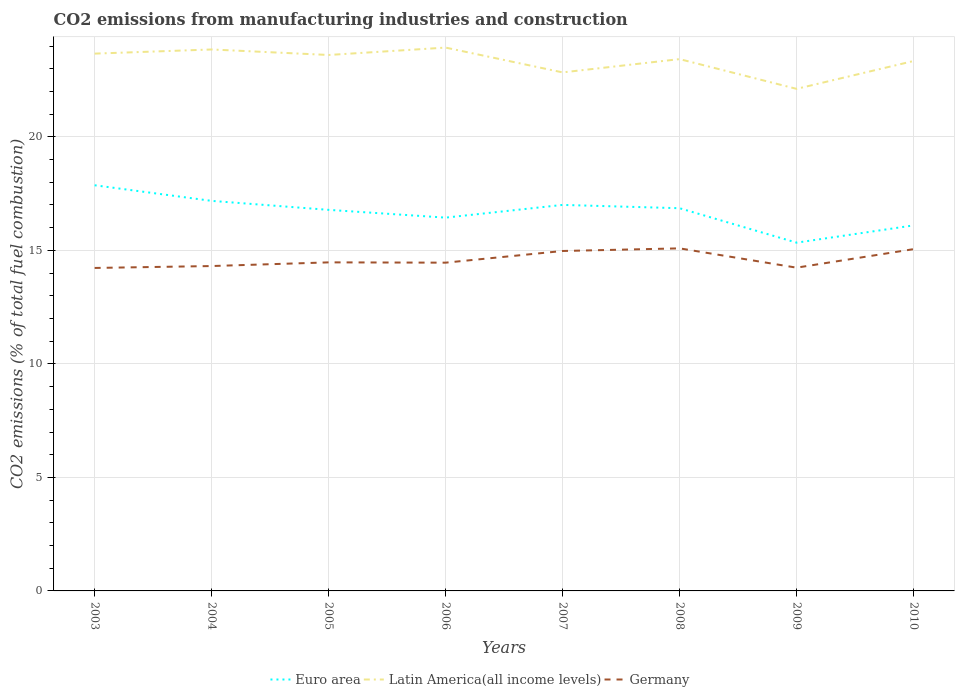How many different coloured lines are there?
Keep it short and to the point. 3. Across all years, what is the maximum amount of CO2 emitted in Euro area?
Provide a succinct answer. 15.34. What is the total amount of CO2 emitted in Germany in the graph?
Your answer should be very brief. -0.08. What is the difference between the highest and the second highest amount of CO2 emitted in Euro area?
Make the answer very short. 2.53. Is the amount of CO2 emitted in Euro area strictly greater than the amount of CO2 emitted in Germany over the years?
Give a very brief answer. No. How many years are there in the graph?
Provide a succinct answer. 8. What is the difference between two consecutive major ticks on the Y-axis?
Your answer should be very brief. 5. Does the graph contain any zero values?
Offer a terse response. No. Does the graph contain grids?
Give a very brief answer. Yes. Where does the legend appear in the graph?
Provide a succinct answer. Bottom center. How are the legend labels stacked?
Your answer should be compact. Horizontal. What is the title of the graph?
Provide a short and direct response. CO2 emissions from manufacturing industries and construction. Does "New Caledonia" appear as one of the legend labels in the graph?
Your response must be concise. No. What is the label or title of the X-axis?
Your response must be concise. Years. What is the label or title of the Y-axis?
Make the answer very short. CO2 emissions (% of total fuel combustion). What is the CO2 emissions (% of total fuel combustion) of Euro area in 2003?
Your answer should be very brief. 17.87. What is the CO2 emissions (% of total fuel combustion) in Latin America(all income levels) in 2003?
Give a very brief answer. 23.67. What is the CO2 emissions (% of total fuel combustion) in Germany in 2003?
Make the answer very short. 14.23. What is the CO2 emissions (% of total fuel combustion) of Euro area in 2004?
Offer a terse response. 17.18. What is the CO2 emissions (% of total fuel combustion) of Latin America(all income levels) in 2004?
Your answer should be compact. 23.85. What is the CO2 emissions (% of total fuel combustion) of Germany in 2004?
Ensure brevity in your answer.  14.31. What is the CO2 emissions (% of total fuel combustion) in Euro area in 2005?
Keep it short and to the point. 16.78. What is the CO2 emissions (% of total fuel combustion) in Latin America(all income levels) in 2005?
Offer a very short reply. 23.61. What is the CO2 emissions (% of total fuel combustion) in Germany in 2005?
Provide a succinct answer. 14.47. What is the CO2 emissions (% of total fuel combustion) of Euro area in 2006?
Give a very brief answer. 16.44. What is the CO2 emissions (% of total fuel combustion) in Latin America(all income levels) in 2006?
Keep it short and to the point. 23.93. What is the CO2 emissions (% of total fuel combustion) of Germany in 2006?
Your response must be concise. 14.46. What is the CO2 emissions (% of total fuel combustion) in Euro area in 2007?
Offer a terse response. 17. What is the CO2 emissions (% of total fuel combustion) of Latin America(all income levels) in 2007?
Your answer should be very brief. 22.84. What is the CO2 emissions (% of total fuel combustion) in Germany in 2007?
Your answer should be very brief. 14.97. What is the CO2 emissions (% of total fuel combustion) in Euro area in 2008?
Your answer should be very brief. 16.86. What is the CO2 emissions (% of total fuel combustion) of Latin America(all income levels) in 2008?
Your response must be concise. 23.42. What is the CO2 emissions (% of total fuel combustion) of Germany in 2008?
Provide a succinct answer. 15.09. What is the CO2 emissions (% of total fuel combustion) in Euro area in 2009?
Provide a succinct answer. 15.34. What is the CO2 emissions (% of total fuel combustion) in Latin America(all income levels) in 2009?
Offer a very short reply. 22.11. What is the CO2 emissions (% of total fuel combustion) of Germany in 2009?
Make the answer very short. 14.24. What is the CO2 emissions (% of total fuel combustion) of Euro area in 2010?
Offer a terse response. 16.1. What is the CO2 emissions (% of total fuel combustion) of Latin America(all income levels) in 2010?
Provide a succinct answer. 23.34. What is the CO2 emissions (% of total fuel combustion) in Germany in 2010?
Your answer should be compact. 15.05. Across all years, what is the maximum CO2 emissions (% of total fuel combustion) of Euro area?
Keep it short and to the point. 17.87. Across all years, what is the maximum CO2 emissions (% of total fuel combustion) in Latin America(all income levels)?
Provide a succinct answer. 23.93. Across all years, what is the maximum CO2 emissions (% of total fuel combustion) of Germany?
Make the answer very short. 15.09. Across all years, what is the minimum CO2 emissions (% of total fuel combustion) of Euro area?
Your answer should be very brief. 15.34. Across all years, what is the minimum CO2 emissions (% of total fuel combustion) in Latin America(all income levels)?
Keep it short and to the point. 22.11. Across all years, what is the minimum CO2 emissions (% of total fuel combustion) of Germany?
Your answer should be very brief. 14.23. What is the total CO2 emissions (% of total fuel combustion) of Euro area in the graph?
Your answer should be compact. 133.58. What is the total CO2 emissions (% of total fuel combustion) of Latin America(all income levels) in the graph?
Your answer should be compact. 186.77. What is the total CO2 emissions (% of total fuel combustion) of Germany in the graph?
Provide a succinct answer. 116.82. What is the difference between the CO2 emissions (% of total fuel combustion) of Euro area in 2003 and that in 2004?
Offer a very short reply. 0.69. What is the difference between the CO2 emissions (% of total fuel combustion) of Latin America(all income levels) in 2003 and that in 2004?
Provide a succinct answer. -0.18. What is the difference between the CO2 emissions (% of total fuel combustion) in Germany in 2003 and that in 2004?
Keep it short and to the point. -0.08. What is the difference between the CO2 emissions (% of total fuel combustion) of Euro area in 2003 and that in 2005?
Ensure brevity in your answer.  1.08. What is the difference between the CO2 emissions (% of total fuel combustion) in Latin America(all income levels) in 2003 and that in 2005?
Provide a succinct answer. 0.06. What is the difference between the CO2 emissions (% of total fuel combustion) in Germany in 2003 and that in 2005?
Keep it short and to the point. -0.25. What is the difference between the CO2 emissions (% of total fuel combustion) in Euro area in 2003 and that in 2006?
Offer a very short reply. 1.43. What is the difference between the CO2 emissions (% of total fuel combustion) of Latin America(all income levels) in 2003 and that in 2006?
Give a very brief answer. -0.27. What is the difference between the CO2 emissions (% of total fuel combustion) of Germany in 2003 and that in 2006?
Make the answer very short. -0.23. What is the difference between the CO2 emissions (% of total fuel combustion) of Euro area in 2003 and that in 2007?
Offer a very short reply. 0.87. What is the difference between the CO2 emissions (% of total fuel combustion) of Latin America(all income levels) in 2003 and that in 2007?
Make the answer very short. 0.83. What is the difference between the CO2 emissions (% of total fuel combustion) of Germany in 2003 and that in 2007?
Your answer should be compact. -0.75. What is the difference between the CO2 emissions (% of total fuel combustion) in Euro area in 2003 and that in 2008?
Provide a succinct answer. 1.01. What is the difference between the CO2 emissions (% of total fuel combustion) in Latin America(all income levels) in 2003 and that in 2008?
Your answer should be compact. 0.24. What is the difference between the CO2 emissions (% of total fuel combustion) in Germany in 2003 and that in 2008?
Your answer should be compact. -0.86. What is the difference between the CO2 emissions (% of total fuel combustion) in Euro area in 2003 and that in 2009?
Ensure brevity in your answer.  2.53. What is the difference between the CO2 emissions (% of total fuel combustion) of Latin America(all income levels) in 2003 and that in 2009?
Your answer should be compact. 1.55. What is the difference between the CO2 emissions (% of total fuel combustion) of Germany in 2003 and that in 2009?
Keep it short and to the point. -0.01. What is the difference between the CO2 emissions (% of total fuel combustion) of Euro area in 2003 and that in 2010?
Provide a short and direct response. 1.77. What is the difference between the CO2 emissions (% of total fuel combustion) in Latin America(all income levels) in 2003 and that in 2010?
Ensure brevity in your answer.  0.33. What is the difference between the CO2 emissions (% of total fuel combustion) in Germany in 2003 and that in 2010?
Offer a very short reply. -0.83. What is the difference between the CO2 emissions (% of total fuel combustion) in Euro area in 2004 and that in 2005?
Make the answer very short. 0.4. What is the difference between the CO2 emissions (% of total fuel combustion) of Latin America(all income levels) in 2004 and that in 2005?
Offer a terse response. 0.24. What is the difference between the CO2 emissions (% of total fuel combustion) in Germany in 2004 and that in 2005?
Your answer should be compact. -0.16. What is the difference between the CO2 emissions (% of total fuel combustion) of Euro area in 2004 and that in 2006?
Keep it short and to the point. 0.74. What is the difference between the CO2 emissions (% of total fuel combustion) of Latin America(all income levels) in 2004 and that in 2006?
Ensure brevity in your answer.  -0.08. What is the difference between the CO2 emissions (% of total fuel combustion) of Germany in 2004 and that in 2006?
Ensure brevity in your answer.  -0.15. What is the difference between the CO2 emissions (% of total fuel combustion) in Euro area in 2004 and that in 2007?
Provide a short and direct response. 0.18. What is the difference between the CO2 emissions (% of total fuel combustion) in Latin America(all income levels) in 2004 and that in 2007?
Your answer should be compact. 1.01. What is the difference between the CO2 emissions (% of total fuel combustion) in Germany in 2004 and that in 2007?
Give a very brief answer. -0.66. What is the difference between the CO2 emissions (% of total fuel combustion) of Euro area in 2004 and that in 2008?
Make the answer very short. 0.32. What is the difference between the CO2 emissions (% of total fuel combustion) of Latin America(all income levels) in 2004 and that in 2008?
Your answer should be very brief. 0.42. What is the difference between the CO2 emissions (% of total fuel combustion) in Germany in 2004 and that in 2008?
Keep it short and to the point. -0.78. What is the difference between the CO2 emissions (% of total fuel combustion) of Euro area in 2004 and that in 2009?
Offer a terse response. 1.84. What is the difference between the CO2 emissions (% of total fuel combustion) of Latin America(all income levels) in 2004 and that in 2009?
Your response must be concise. 1.73. What is the difference between the CO2 emissions (% of total fuel combustion) in Germany in 2004 and that in 2009?
Make the answer very short. 0.07. What is the difference between the CO2 emissions (% of total fuel combustion) of Latin America(all income levels) in 2004 and that in 2010?
Your answer should be very brief. 0.51. What is the difference between the CO2 emissions (% of total fuel combustion) of Germany in 2004 and that in 2010?
Your answer should be compact. -0.74. What is the difference between the CO2 emissions (% of total fuel combustion) in Euro area in 2005 and that in 2006?
Offer a terse response. 0.34. What is the difference between the CO2 emissions (% of total fuel combustion) of Latin America(all income levels) in 2005 and that in 2006?
Offer a very short reply. -0.33. What is the difference between the CO2 emissions (% of total fuel combustion) in Germany in 2005 and that in 2006?
Provide a short and direct response. 0.01. What is the difference between the CO2 emissions (% of total fuel combustion) in Euro area in 2005 and that in 2007?
Provide a short and direct response. -0.22. What is the difference between the CO2 emissions (% of total fuel combustion) of Latin America(all income levels) in 2005 and that in 2007?
Your response must be concise. 0.77. What is the difference between the CO2 emissions (% of total fuel combustion) in Germany in 2005 and that in 2007?
Provide a succinct answer. -0.5. What is the difference between the CO2 emissions (% of total fuel combustion) in Euro area in 2005 and that in 2008?
Make the answer very short. -0.07. What is the difference between the CO2 emissions (% of total fuel combustion) of Latin America(all income levels) in 2005 and that in 2008?
Your answer should be compact. 0.18. What is the difference between the CO2 emissions (% of total fuel combustion) of Germany in 2005 and that in 2008?
Keep it short and to the point. -0.62. What is the difference between the CO2 emissions (% of total fuel combustion) in Euro area in 2005 and that in 2009?
Provide a short and direct response. 1.44. What is the difference between the CO2 emissions (% of total fuel combustion) of Latin America(all income levels) in 2005 and that in 2009?
Your answer should be compact. 1.49. What is the difference between the CO2 emissions (% of total fuel combustion) of Germany in 2005 and that in 2009?
Your answer should be compact. 0.23. What is the difference between the CO2 emissions (% of total fuel combustion) in Euro area in 2005 and that in 2010?
Your answer should be very brief. 0.68. What is the difference between the CO2 emissions (% of total fuel combustion) of Latin America(all income levels) in 2005 and that in 2010?
Offer a very short reply. 0.27. What is the difference between the CO2 emissions (% of total fuel combustion) of Germany in 2005 and that in 2010?
Keep it short and to the point. -0.58. What is the difference between the CO2 emissions (% of total fuel combustion) of Euro area in 2006 and that in 2007?
Your answer should be very brief. -0.56. What is the difference between the CO2 emissions (% of total fuel combustion) in Latin America(all income levels) in 2006 and that in 2007?
Keep it short and to the point. 1.09. What is the difference between the CO2 emissions (% of total fuel combustion) of Germany in 2006 and that in 2007?
Provide a succinct answer. -0.51. What is the difference between the CO2 emissions (% of total fuel combustion) of Euro area in 2006 and that in 2008?
Keep it short and to the point. -0.41. What is the difference between the CO2 emissions (% of total fuel combustion) in Latin America(all income levels) in 2006 and that in 2008?
Provide a short and direct response. 0.51. What is the difference between the CO2 emissions (% of total fuel combustion) of Germany in 2006 and that in 2008?
Offer a terse response. -0.63. What is the difference between the CO2 emissions (% of total fuel combustion) in Euro area in 2006 and that in 2009?
Provide a short and direct response. 1.1. What is the difference between the CO2 emissions (% of total fuel combustion) in Latin America(all income levels) in 2006 and that in 2009?
Ensure brevity in your answer.  1.82. What is the difference between the CO2 emissions (% of total fuel combustion) of Germany in 2006 and that in 2009?
Your answer should be very brief. 0.22. What is the difference between the CO2 emissions (% of total fuel combustion) of Euro area in 2006 and that in 2010?
Make the answer very short. 0.34. What is the difference between the CO2 emissions (% of total fuel combustion) in Latin America(all income levels) in 2006 and that in 2010?
Keep it short and to the point. 0.59. What is the difference between the CO2 emissions (% of total fuel combustion) in Germany in 2006 and that in 2010?
Offer a very short reply. -0.6. What is the difference between the CO2 emissions (% of total fuel combustion) of Euro area in 2007 and that in 2008?
Your response must be concise. 0.15. What is the difference between the CO2 emissions (% of total fuel combustion) of Latin America(all income levels) in 2007 and that in 2008?
Provide a short and direct response. -0.59. What is the difference between the CO2 emissions (% of total fuel combustion) of Germany in 2007 and that in 2008?
Offer a terse response. -0.12. What is the difference between the CO2 emissions (% of total fuel combustion) in Euro area in 2007 and that in 2009?
Offer a terse response. 1.66. What is the difference between the CO2 emissions (% of total fuel combustion) in Latin America(all income levels) in 2007 and that in 2009?
Provide a short and direct response. 0.72. What is the difference between the CO2 emissions (% of total fuel combustion) in Germany in 2007 and that in 2009?
Ensure brevity in your answer.  0.73. What is the difference between the CO2 emissions (% of total fuel combustion) in Euro area in 2007 and that in 2010?
Give a very brief answer. 0.9. What is the difference between the CO2 emissions (% of total fuel combustion) in Latin America(all income levels) in 2007 and that in 2010?
Keep it short and to the point. -0.5. What is the difference between the CO2 emissions (% of total fuel combustion) of Germany in 2007 and that in 2010?
Offer a terse response. -0.08. What is the difference between the CO2 emissions (% of total fuel combustion) of Euro area in 2008 and that in 2009?
Provide a short and direct response. 1.52. What is the difference between the CO2 emissions (% of total fuel combustion) in Latin America(all income levels) in 2008 and that in 2009?
Keep it short and to the point. 1.31. What is the difference between the CO2 emissions (% of total fuel combustion) of Germany in 2008 and that in 2009?
Your response must be concise. 0.85. What is the difference between the CO2 emissions (% of total fuel combustion) of Euro area in 2008 and that in 2010?
Provide a short and direct response. 0.76. What is the difference between the CO2 emissions (% of total fuel combustion) in Latin America(all income levels) in 2008 and that in 2010?
Your answer should be very brief. 0.08. What is the difference between the CO2 emissions (% of total fuel combustion) of Germany in 2008 and that in 2010?
Keep it short and to the point. 0.03. What is the difference between the CO2 emissions (% of total fuel combustion) in Euro area in 2009 and that in 2010?
Your answer should be very brief. -0.76. What is the difference between the CO2 emissions (% of total fuel combustion) of Latin America(all income levels) in 2009 and that in 2010?
Keep it short and to the point. -1.23. What is the difference between the CO2 emissions (% of total fuel combustion) in Germany in 2009 and that in 2010?
Ensure brevity in your answer.  -0.82. What is the difference between the CO2 emissions (% of total fuel combustion) of Euro area in 2003 and the CO2 emissions (% of total fuel combustion) of Latin America(all income levels) in 2004?
Offer a very short reply. -5.98. What is the difference between the CO2 emissions (% of total fuel combustion) of Euro area in 2003 and the CO2 emissions (% of total fuel combustion) of Germany in 2004?
Provide a succinct answer. 3.56. What is the difference between the CO2 emissions (% of total fuel combustion) of Latin America(all income levels) in 2003 and the CO2 emissions (% of total fuel combustion) of Germany in 2004?
Provide a short and direct response. 9.36. What is the difference between the CO2 emissions (% of total fuel combustion) of Euro area in 2003 and the CO2 emissions (% of total fuel combustion) of Latin America(all income levels) in 2005?
Your answer should be compact. -5.74. What is the difference between the CO2 emissions (% of total fuel combustion) of Euro area in 2003 and the CO2 emissions (% of total fuel combustion) of Germany in 2005?
Offer a terse response. 3.4. What is the difference between the CO2 emissions (% of total fuel combustion) of Latin America(all income levels) in 2003 and the CO2 emissions (% of total fuel combustion) of Germany in 2005?
Your answer should be compact. 9.19. What is the difference between the CO2 emissions (% of total fuel combustion) of Euro area in 2003 and the CO2 emissions (% of total fuel combustion) of Latin America(all income levels) in 2006?
Make the answer very short. -6.06. What is the difference between the CO2 emissions (% of total fuel combustion) in Euro area in 2003 and the CO2 emissions (% of total fuel combustion) in Germany in 2006?
Give a very brief answer. 3.41. What is the difference between the CO2 emissions (% of total fuel combustion) of Latin America(all income levels) in 2003 and the CO2 emissions (% of total fuel combustion) of Germany in 2006?
Keep it short and to the point. 9.21. What is the difference between the CO2 emissions (% of total fuel combustion) in Euro area in 2003 and the CO2 emissions (% of total fuel combustion) in Latin America(all income levels) in 2007?
Provide a short and direct response. -4.97. What is the difference between the CO2 emissions (% of total fuel combustion) in Euro area in 2003 and the CO2 emissions (% of total fuel combustion) in Germany in 2007?
Give a very brief answer. 2.9. What is the difference between the CO2 emissions (% of total fuel combustion) of Latin America(all income levels) in 2003 and the CO2 emissions (% of total fuel combustion) of Germany in 2007?
Provide a short and direct response. 8.69. What is the difference between the CO2 emissions (% of total fuel combustion) of Euro area in 2003 and the CO2 emissions (% of total fuel combustion) of Latin America(all income levels) in 2008?
Your response must be concise. -5.56. What is the difference between the CO2 emissions (% of total fuel combustion) in Euro area in 2003 and the CO2 emissions (% of total fuel combustion) in Germany in 2008?
Give a very brief answer. 2.78. What is the difference between the CO2 emissions (% of total fuel combustion) of Latin America(all income levels) in 2003 and the CO2 emissions (% of total fuel combustion) of Germany in 2008?
Provide a short and direct response. 8.58. What is the difference between the CO2 emissions (% of total fuel combustion) in Euro area in 2003 and the CO2 emissions (% of total fuel combustion) in Latin America(all income levels) in 2009?
Keep it short and to the point. -4.25. What is the difference between the CO2 emissions (% of total fuel combustion) in Euro area in 2003 and the CO2 emissions (% of total fuel combustion) in Germany in 2009?
Provide a short and direct response. 3.63. What is the difference between the CO2 emissions (% of total fuel combustion) of Latin America(all income levels) in 2003 and the CO2 emissions (% of total fuel combustion) of Germany in 2009?
Keep it short and to the point. 9.43. What is the difference between the CO2 emissions (% of total fuel combustion) in Euro area in 2003 and the CO2 emissions (% of total fuel combustion) in Latin America(all income levels) in 2010?
Provide a short and direct response. -5.47. What is the difference between the CO2 emissions (% of total fuel combustion) in Euro area in 2003 and the CO2 emissions (% of total fuel combustion) in Germany in 2010?
Your answer should be compact. 2.81. What is the difference between the CO2 emissions (% of total fuel combustion) in Latin America(all income levels) in 2003 and the CO2 emissions (% of total fuel combustion) in Germany in 2010?
Offer a terse response. 8.61. What is the difference between the CO2 emissions (% of total fuel combustion) in Euro area in 2004 and the CO2 emissions (% of total fuel combustion) in Latin America(all income levels) in 2005?
Keep it short and to the point. -6.43. What is the difference between the CO2 emissions (% of total fuel combustion) in Euro area in 2004 and the CO2 emissions (% of total fuel combustion) in Germany in 2005?
Provide a succinct answer. 2.71. What is the difference between the CO2 emissions (% of total fuel combustion) in Latin America(all income levels) in 2004 and the CO2 emissions (% of total fuel combustion) in Germany in 2005?
Offer a terse response. 9.38. What is the difference between the CO2 emissions (% of total fuel combustion) of Euro area in 2004 and the CO2 emissions (% of total fuel combustion) of Latin America(all income levels) in 2006?
Offer a terse response. -6.75. What is the difference between the CO2 emissions (% of total fuel combustion) in Euro area in 2004 and the CO2 emissions (% of total fuel combustion) in Germany in 2006?
Keep it short and to the point. 2.72. What is the difference between the CO2 emissions (% of total fuel combustion) in Latin America(all income levels) in 2004 and the CO2 emissions (% of total fuel combustion) in Germany in 2006?
Provide a succinct answer. 9.39. What is the difference between the CO2 emissions (% of total fuel combustion) of Euro area in 2004 and the CO2 emissions (% of total fuel combustion) of Latin America(all income levels) in 2007?
Your answer should be compact. -5.66. What is the difference between the CO2 emissions (% of total fuel combustion) in Euro area in 2004 and the CO2 emissions (% of total fuel combustion) in Germany in 2007?
Your response must be concise. 2.21. What is the difference between the CO2 emissions (% of total fuel combustion) of Latin America(all income levels) in 2004 and the CO2 emissions (% of total fuel combustion) of Germany in 2007?
Ensure brevity in your answer.  8.88. What is the difference between the CO2 emissions (% of total fuel combustion) in Euro area in 2004 and the CO2 emissions (% of total fuel combustion) in Latin America(all income levels) in 2008?
Ensure brevity in your answer.  -6.24. What is the difference between the CO2 emissions (% of total fuel combustion) in Euro area in 2004 and the CO2 emissions (% of total fuel combustion) in Germany in 2008?
Your answer should be compact. 2.09. What is the difference between the CO2 emissions (% of total fuel combustion) in Latin America(all income levels) in 2004 and the CO2 emissions (% of total fuel combustion) in Germany in 2008?
Offer a very short reply. 8.76. What is the difference between the CO2 emissions (% of total fuel combustion) in Euro area in 2004 and the CO2 emissions (% of total fuel combustion) in Latin America(all income levels) in 2009?
Your answer should be compact. -4.93. What is the difference between the CO2 emissions (% of total fuel combustion) of Euro area in 2004 and the CO2 emissions (% of total fuel combustion) of Germany in 2009?
Give a very brief answer. 2.94. What is the difference between the CO2 emissions (% of total fuel combustion) in Latin America(all income levels) in 2004 and the CO2 emissions (% of total fuel combustion) in Germany in 2009?
Your answer should be very brief. 9.61. What is the difference between the CO2 emissions (% of total fuel combustion) in Euro area in 2004 and the CO2 emissions (% of total fuel combustion) in Latin America(all income levels) in 2010?
Offer a very short reply. -6.16. What is the difference between the CO2 emissions (% of total fuel combustion) of Euro area in 2004 and the CO2 emissions (% of total fuel combustion) of Germany in 2010?
Your answer should be compact. 2.13. What is the difference between the CO2 emissions (% of total fuel combustion) in Latin America(all income levels) in 2004 and the CO2 emissions (% of total fuel combustion) in Germany in 2010?
Provide a succinct answer. 8.79. What is the difference between the CO2 emissions (% of total fuel combustion) in Euro area in 2005 and the CO2 emissions (% of total fuel combustion) in Latin America(all income levels) in 2006?
Your answer should be compact. -7.15. What is the difference between the CO2 emissions (% of total fuel combustion) in Euro area in 2005 and the CO2 emissions (% of total fuel combustion) in Germany in 2006?
Provide a succinct answer. 2.33. What is the difference between the CO2 emissions (% of total fuel combustion) in Latin America(all income levels) in 2005 and the CO2 emissions (% of total fuel combustion) in Germany in 2006?
Offer a very short reply. 9.15. What is the difference between the CO2 emissions (% of total fuel combustion) in Euro area in 2005 and the CO2 emissions (% of total fuel combustion) in Latin America(all income levels) in 2007?
Provide a succinct answer. -6.05. What is the difference between the CO2 emissions (% of total fuel combustion) of Euro area in 2005 and the CO2 emissions (% of total fuel combustion) of Germany in 2007?
Give a very brief answer. 1.81. What is the difference between the CO2 emissions (% of total fuel combustion) of Latin America(all income levels) in 2005 and the CO2 emissions (% of total fuel combustion) of Germany in 2007?
Your response must be concise. 8.63. What is the difference between the CO2 emissions (% of total fuel combustion) of Euro area in 2005 and the CO2 emissions (% of total fuel combustion) of Latin America(all income levels) in 2008?
Make the answer very short. -6.64. What is the difference between the CO2 emissions (% of total fuel combustion) in Euro area in 2005 and the CO2 emissions (% of total fuel combustion) in Germany in 2008?
Your answer should be very brief. 1.7. What is the difference between the CO2 emissions (% of total fuel combustion) of Latin America(all income levels) in 2005 and the CO2 emissions (% of total fuel combustion) of Germany in 2008?
Ensure brevity in your answer.  8.52. What is the difference between the CO2 emissions (% of total fuel combustion) in Euro area in 2005 and the CO2 emissions (% of total fuel combustion) in Latin America(all income levels) in 2009?
Offer a terse response. -5.33. What is the difference between the CO2 emissions (% of total fuel combustion) in Euro area in 2005 and the CO2 emissions (% of total fuel combustion) in Germany in 2009?
Ensure brevity in your answer.  2.55. What is the difference between the CO2 emissions (% of total fuel combustion) of Latin America(all income levels) in 2005 and the CO2 emissions (% of total fuel combustion) of Germany in 2009?
Your answer should be very brief. 9.37. What is the difference between the CO2 emissions (% of total fuel combustion) of Euro area in 2005 and the CO2 emissions (% of total fuel combustion) of Latin America(all income levels) in 2010?
Provide a succinct answer. -6.56. What is the difference between the CO2 emissions (% of total fuel combustion) of Euro area in 2005 and the CO2 emissions (% of total fuel combustion) of Germany in 2010?
Give a very brief answer. 1.73. What is the difference between the CO2 emissions (% of total fuel combustion) of Latin America(all income levels) in 2005 and the CO2 emissions (% of total fuel combustion) of Germany in 2010?
Offer a very short reply. 8.55. What is the difference between the CO2 emissions (% of total fuel combustion) of Euro area in 2006 and the CO2 emissions (% of total fuel combustion) of Latin America(all income levels) in 2007?
Ensure brevity in your answer.  -6.4. What is the difference between the CO2 emissions (% of total fuel combustion) in Euro area in 2006 and the CO2 emissions (% of total fuel combustion) in Germany in 2007?
Give a very brief answer. 1.47. What is the difference between the CO2 emissions (% of total fuel combustion) in Latin America(all income levels) in 2006 and the CO2 emissions (% of total fuel combustion) in Germany in 2007?
Your answer should be very brief. 8.96. What is the difference between the CO2 emissions (% of total fuel combustion) of Euro area in 2006 and the CO2 emissions (% of total fuel combustion) of Latin America(all income levels) in 2008?
Provide a short and direct response. -6.98. What is the difference between the CO2 emissions (% of total fuel combustion) of Euro area in 2006 and the CO2 emissions (% of total fuel combustion) of Germany in 2008?
Your response must be concise. 1.35. What is the difference between the CO2 emissions (% of total fuel combustion) of Latin America(all income levels) in 2006 and the CO2 emissions (% of total fuel combustion) of Germany in 2008?
Offer a terse response. 8.84. What is the difference between the CO2 emissions (% of total fuel combustion) in Euro area in 2006 and the CO2 emissions (% of total fuel combustion) in Latin America(all income levels) in 2009?
Offer a terse response. -5.67. What is the difference between the CO2 emissions (% of total fuel combustion) of Euro area in 2006 and the CO2 emissions (% of total fuel combustion) of Germany in 2009?
Provide a short and direct response. 2.2. What is the difference between the CO2 emissions (% of total fuel combustion) in Latin America(all income levels) in 2006 and the CO2 emissions (% of total fuel combustion) in Germany in 2009?
Your answer should be very brief. 9.69. What is the difference between the CO2 emissions (% of total fuel combustion) of Euro area in 2006 and the CO2 emissions (% of total fuel combustion) of Latin America(all income levels) in 2010?
Give a very brief answer. -6.9. What is the difference between the CO2 emissions (% of total fuel combustion) in Euro area in 2006 and the CO2 emissions (% of total fuel combustion) in Germany in 2010?
Provide a succinct answer. 1.39. What is the difference between the CO2 emissions (% of total fuel combustion) of Latin America(all income levels) in 2006 and the CO2 emissions (% of total fuel combustion) of Germany in 2010?
Your answer should be very brief. 8.88. What is the difference between the CO2 emissions (% of total fuel combustion) of Euro area in 2007 and the CO2 emissions (% of total fuel combustion) of Latin America(all income levels) in 2008?
Your response must be concise. -6.42. What is the difference between the CO2 emissions (% of total fuel combustion) of Euro area in 2007 and the CO2 emissions (% of total fuel combustion) of Germany in 2008?
Your answer should be compact. 1.91. What is the difference between the CO2 emissions (% of total fuel combustion) in Latin America(all income levels) in 2007 and the CO2 emissions (% of total fuel combustion) in Germany in 2008?
Keep it short and to the point. 7.75. What is the difference between the CO2 emissions (% of total fuel combustion) of Euro area in 2007 and the CO2 emissions (% of total fuel combustion) of Latin America(all income levels) in 2009?
Ensure brevity in your answer.  -5.11. What is the difference between the CO2 emissions (% of total fuel combustion) in Euro area in 2007 and the CO2 emissions (% of total fuel combustion) in Germany in 2009?
Offer a very short reply. 2.76. What is the difference between the CO2 emissions (% of total fuel combustion) in Latin America(all income levels) in 2007 and the CO2 emissions (% of total fuel combustion) in Germany in 2009?
Keep it short and to the point. 8.6. What is the difference between the CO2 emissions (% of total fuel combustion) of Euro area in 2007 and the CO2 emissions (% of total fuel combustion) of Latin America(all income levels) in 2010?
Your response must be concise. -6.34. What is the difference between the CO2 emissions (% of total fuel combustion) in Euro area in 2007 and the CO2 emissions (% of total fuel combustion) in Germany in 2010?
Make the answer very short. 1.95. What is the difference between the CO2 emissions (% of total fuel combustion) in Latin America(all income levels) in 2007 and the CO2 emissions (% of total fuel combustion) in Germany in 2010?
Ensure brevity in your answer.  7.79. What is the difference between the CO2 emissions (% of total fuel combustion) in Euro area in 2008 and the CO2 emissions (% of total fuel combustion) in Latin America(all income levels) in 2009?
Give a very brief answer. -5.26. What is the difference between the CO2 emissions (% of total fuel combustion) of Euro area in 2008 and the CO2 emissions (% of total fuel combustion) of Germany in 2009?
Ensure brevity in your answer.  2.62. What is the difference between the CO2 emissions (% of total fuel combustion) in Latin America(all income levels) in 2008 and the CO2 emissions (% of total fuel combustion) in Germany in 2009?
Your answer should be compact. 9.19. What is the difference between the CO2 emissions (% of total fuel combustion) in Euro area in 2008 and the CO2 emissions (% of total fuel combustion) in Latin America(all income levels) in 2010?
Keep it short and to the point. -6.48. What is the difference between the CO2 emissions (% of total fuel combustion) of Euro area in 2008 and the CO2 emissions (% of total fuel combustion) of Germany in 2010?
Give a very brief answer. 1.8. What is the difference between the CO2 emissions (% of total fuel combustion) in Latin America(all income levels) in 2008 and the CO2 emissions (% of total fuel combustion) in Germany in 2010?
Provide a succinct answer. 8.37. What is the difference between the CO2 emissions (% of total fuel combustion) in Euro area in 2009 and the CO2 emissions (% of total fuel combustion) in Latin America(all income levels) in 2010?
Your answer should be very brief. -8. What is the difference between the CO2 emissions (% of total fuel combustion) of Euro area in 2009 and the CO2 emissions (% of total fuel combustion) of Germany in 2010?
Offer a terse response. 0.29. What is the difference between the CO2 emissions (% of total fuel combustion) in Latin America(all income levels) in 2009 and the CO2 emissions (% of total fuel combustion) in Germany in 2010?
Your answer should be very brief. 7.06. What is the average CO2 emissions (% of total fuel combustion) of Euro area per year?
Provide a short and direct response. 16.7. What is the average CO2 emissions (% of total fuel combustion) of Latin America(all income levels) per year?
Offer a terse response. 23.35. What is the average CO2 emissions (% of total fuel combustion) in Germany per year?
Give a very brief answer. 14.6. In the year 2003, what is the difference between the CO2 emissions (% of total fuel combustion) of Euro area and CO2 emissions (% of total fuel combustion) of Latin America(all income levels)?
Offer a very short reply. -5.8. In the year 2003, what is the difference between the CO2 emissions (% of total fuel combustion) of Euro area and CO2 emissions (% of total fuel combustion) of Germany?
Your answer should be compact. 3.64. In the year 2003, what is the difference between the CO2 emissions (% of total fuel combustion) of Latin America(all income levels) and CO2 emissions (% of total fuel combustion) of Germany?
Your answer should be compact. 9.44. In the year 2004, what is the difference between the CO2 emissions (% of total fuel combustion) of Euro area and CO2 emissions (% of total fuel combustion) of Latin America(all income levels)?
Offer a very short reply. -6.67. In the year 2004, what is the difference between the CO2 emissions (% of total fuel combustion) of Euro area and CO2 emissions (% of total fuel combustion) of Germany?
Provide a succinct answer. 2.87. In the year 2004, what is the difference between the CO2 emissions (% of total fuel combustion) of Latin America(all income levels) and CO2 emissions (% of total fuel combustion) of Germany?
Your answer should be very brief. 9.54. In the year 2005, what is the difference between the CO2 emissions (% of total fuel combustion) of Euro area and CO2 emissions (% of total fuel combustion) of Latin America(all income levels)?
Make the answer very short. -6.82. In the year 2005, what is the difference between the CO2 emissions (% of total fuel combustion) in Euro area and CO2 emissions (% of total fuel combustion) in Germany?
Make the answer very short. 2.31. In the year 2005, what is the difference between the CO2 emissions (% of total fuel combustion) of Latin America(all income levels) and CO2 emissions (% of total fuel combustion) of Germany?
Make the answer very short. 9.13. In the year 2006, what is the difference between the CO2 emissions (% of total fuel combustion) of Euro area and CO2 emissions (% of total fuel combustion) of Latin America(all income levels)?
Offer a very short reply. -7.49. In the year 2006, what is the difference between the CO2 emissions (% of total fuel combustion) of Euro area and CO2 emissions (% of total fuel combustion) of Germany?
Make the answer very short. 1.98. In the year 2006, what is the difference between the CO2 emissions (% of total fuel combustion) of Latin America(all income levels) and CO2 emissions (% of total fuel combustion) of Germany?
Give a very brief answer. 9.47. In the year 2007, what is the difference between the CO2 emissions (% of total fuel combustion) in Euro area and CO2 emissions (% of total fuel combustion) in Latin America(all income levels)?
Your response must be concise. -5.84. In the year 2007, what is the difference between the CO2 emissions (% of total fuel combustion) in Euro area and CO2 emissions (% of total fuel combustion) in Germany?
Keep it short and to the point. 2.03. In the year 2007, what is the difference between the CO2 emissions (% of total fuel combustion) in Latin America(all income levels) and CO2 emissions (% of total fuel combustion) in Germany?
Provide a short and direct response. 7.87. In the year 2008, what is the difference between the CO2 emissions (% of total fuel combustion) in Euro area and CO2 emissions (% of total fuel combustion) in Latin America(all income levels)?
Your response must be concise. -6.57. In the year 2008, what is the difference between the CO2 emissions (% of total fuel combustion) of Euro area and CO2 emissions (% of total fuel combustion) of Germany?
Keep it short and to the point. 1.77. In the year 2008, what is the difference between the CO2 emissions (% of total fuel combustion) of Latin America(all income levels) and CO2 emissions (% of total fuel combustion) of Germany?
Keep it short and to the point. 8.34. In the year 2009, what is the difference between the CO2 emissions (% of total fuel combustion) in Euro area and CO2 emissions (% of total fuel combustion) in Latin America(all income levels)?
Provide a succinct answer. -6.77. In the year 2009, what is the difference between the CO2 emissions (% of total fuel combustion) of Euro area and CO2 emissions (% of total fuel combustion) of Germany?
Keep it short and to the point. 1.1. In the year 2009, what is the difference between the CO2 emissions (% of total fuel combustion) of Latin America(all income levels) and CO2 emissions (% of total fuel combustion) of Germany?
Offer a terse response. 7.88. In the year 2010, what is the difference between the CO2 emissions (% of total fuel combustion) of Euro area and CO2 emissions (% of total fuel combustion) of Latin America(all income levels)?
Provide a short and direct response. -7.24. In the year 2010, what is the difference between the CO2 emissions (% of total fuel combustion) of Euro area and CO2 emissions (% of total fuel combustion) of Germany?
Keep it short and to the point. 1.05. In the year 2010, what is the difference between the CO2 emissions (% of total fuel combustion) of Latin America(all income levels) and CO2 emissions (% of total fuel combustion) of Germany?
Keep it short and to the point. 8.29. What is the ratio of the CO2 emissions (% of total fuel combustion) of Euro area in 2003 to that in 2004?
Your answer should be compact. 1.04. What is the ratio of the CO2 emissions (% of total fuel combustion) of Germany in 2003 to that in 2004?
Provide a succinct answer. 0.99. What is the ratio of the CO2 emissions (% of total fuel combustion) of Euro area in 2003 to that in 2005?
Your answer should be compact. 1.06. What is the ratio of the CO2 emissions (% of total fuel combustion) of Latin America(all income levels) in 2003 to that in 2005?
Offer a very short reply. 1. What is the ratio of the CO2 emissions (% of total fuel combustion) of Germany in 2003 to that in 2005?
Offer a very short reply. 0.98. What is the ratio of the CO2 emissions (% of total fuel combustion) of Euro area in 2003 to that in 2006?
Your answer should be compact. 1.09. What is the ratio of the CO2 emissions (% of total fuel combustion) of Latin America(all income levels) in 2003 to that in 2006?
Provide a short and direct response. 0.99. What is the ratio of the CO2 emissions (% of total fuel combustion) in Germany in 2003 to that in 2006?
Offer a very short reply. 0.98. What is the ratio of the CO2 emissions (% of total fuel combustion) of Euro area in 2003 to that in 2007?
Ensure brevity in your answer.  1.05. What is the ratio of the CO2 emissions (% of total fuel combustion) of Latin America(all income levels) in 2003 to that in 2007?
Provide a succinct answer. 1.04. What is the ratio of the CO2 emissions (% of total fuel combustion) of Germany in 2003 to that in 2007?
Offer a very short reply. 0.95. What is the ratio of the CO2 emissions (% of total fuel combustion) in Euro area in 2003 to that in 2008?
Make the answer very short. 1.06. What is the ratio of the CO2 emissions (% of total fuel combustion) of Latin America(all income levels) in 2003 to that in 2008?
Your answer should be compact. 1.01. What is the ratio of the CO2 emissions (% of total fuel combustion) of Germany in 2003 to that in 2008?
Ensure brevity in your answer.  0.94. What is the ratio of the CO2 emissions (% of total fuel combustion) in Euro area in 2003 to that in 2009?
Your answer should be very brief. 1.16. What is the ratio of the CO2 emissions (% of total fuel combustion) of Latin America(all income levels) in 2003 to that in 2009?
Your answer should be compact. 1.07. What is the ratio of the CO2 emissions (% of total fuel combustion) in Germany in 2003 to that in 2009?
Provide a short and direct response. 1. What is the ratio of the CO2 emissions (% of total fuel combustion) in Euro area in 2003 to that in 2010?
Make the answer very short. 1.11. What is the ratio of the CO2 emissions (% of total fuel combustion) in Latin America(all income levels) in 2003 to that in 2010?
Ensure brevity in your answer.  1.01. What is the ratio of the CO2 emissions (% of total fuel combustion) of Germany in 2003 to that in 2010?
Offer a very short reply. 0.94. What is the ratio of the CO2 emissions (% of total fuel combustion) of Euro area in 2004 to that in 2005?
Your answer should be compact. 1.02. What is the ratio of the CO2 emissions (% of total fuel combustion) of Latin America(all income levels) in 2004 to that in 2005?
Ensure brevity in your answer.  1.01. What is the ratio of the CO2 emissions (% of total fuel combustion) of Germany in 2004 to that in 2005?
Ensure brevity in your answer.  0.99. What is the ratio of the CO2 emissions (% of total fuel combustion) in Euro area in 2004 to that in 2006?
Offer a terse response. 1.04. What is the ratio of the CO2 emissions (% of total fuel combustion) in Latin America(all income levels) in 2004 to that in 2006?
Keep it short and to the point. 1. What is the ratio of the CO2 emissions (% of total fuel combustion) of Euro area in 2004 to that in 2007?
Your response must be concise. 1.01. What is the ratio of the CO2 emissions (% of total fuel combustion) in Latin America(all income levels) in 2004 to that in 2007?
Keep it short and to the point. 1.04. What is the ratio of the CO2 emissions (% of total fuel combustion) in Germany in 2004 to that in 2007?
Provide a succinct answer. 0.96. What is the ratio of the CO2 emissions (% of total fuel combustion) in Euro area in 2004 to that in 2008?
Your response must be concise. 1.02. What is the ratio of the CO2 emissions (% of total fuel combustion) of Latin America(all income levels) in 2004 to that in 2008?
Keep it short and to the point. 1.02. What is the ratio of the CO2 emissions (% of total fuel combustion) in Germany in 2004 to that in 2008?
Offer a very short reply. 0.95. What is the ratio of the CO2 emissions (% of total fuel combustion) in Euro area in 2004 to that in 2009?
Provide a short and direct response. 1.12. What is the ratio of the CO2 emissions (% of total fuel combustion) in Latin America(all income levels) in 2004 to that in 2009?
Give a very brief answer. 1.08. What is the ratio of the CO2 emissions (% of total fuel combustion) of Germany in 2004 to that in 2009?
Your answer should be very brief. 1. What is the ratio of the CO2 emissions (% of total fuel combustion) in Euro area in 2004 to that in 2010?
Keep it short and to the point. 1.07. What is the ratio of the CO2 emissions (% of total fuel combustion) in Latin America(all income levels) in 2004 to that in 2010?
Offer a terse response. 1.02. What is the ratio of the CO2 emissions (% of total fuel combustion) of Germany in 2004 to that in 2010?
Make the answer very short. 0.95. What is the ratio of the CO2 emissions (% of total fuel combustion) in Euro area in 2005 to that in 2006?
Ensure brevity in your answer.  1.02. What is the ratio of the CO2 emissions (% of total fuel combustion) in Latin America(all income levels) in 2005 to that in 2006?
Your answer should be compact. 0.99. What is the ratio of the CO2 emissions (% of total fuel combustion) of Euro area in 2005 to that in 2007?
Ensure brevity in your answer.  0.99. What is the ratio of the CO2 emissions (% of total fuel combustion) in Latin America(all income levels) in 2005 to that in 2007?
Provide a succinct answer. 1.03. What is the ratio of the CO2 emissions (% of total fuel combustion) in Germany in 2005 to that in 2007?
Keep it short and to the point. 0.97. What is the ratio of the CO2 emissions (% of total fuel combustion) of Euro area in 2005 to that in 2008?
Keep it short and to the point. 1. What is the ratio of the CO2 emissions (% of total fuel combustion) in Latin America(all income levels) in 2005 to that in 2008?
Keep it short and to the point. 1.01. What is the ratio of the CO2 emissions (% of total fuel combustion) of Germany in 2005 to that in 2008?
Provide a short and direct response. 0.96. What is the ratio of the CO2 emissions (% of total fuel combustion) in Euro area in 2005 to that in 2009?
Your response must be concise. 1.09. What is the ratio of the CO2 emissions (% of total fuel combustion) of Latin America(all income levels) in 2005 to that in 2009?
Provide a succinct answer. 1.07. What is the ratio of the CO2 emissions (% of total fuel combustion) in Germany in 2005 to that in 2009?
Provide a succinct answer. 1.02. What is the ratio of the CO2 emissions (% of total fuel combustion) in Euro area in 2005 to that in 2010?
Your answer should be very brief. 1.04. What is the ratio of the CO2 emissions (% of total fuel combustion) of Latin America(all income levels) in 2005 to that in 2010?
Give a very brief answer. 1.01. What is the ratio of the CO2 emissions (% of total fuel combustion) in Germany in 2005 to that in 2010?
Your answer should be very brief. 0.96. What is the ratio of the CO2 emissions (% of total fuel combustion) of Euro area in 2006 to that in 2007?
Provide a succinct answer. 0.97. What is the ratio of the CO2 emissions (% of total fuel combustion) in Latin America(all income levels) in 2006 to that in 2007?
Ensure brevity in your answer.  1.05. What is the ratio of the CO2 emissions (% of total fuel combustion) in Germany in 2006 to that in 2007?
Your response must be concise. 0.97. What is the ratio of the CO2 emissions (% of total fuel combustion) of Euro area in 2006 to that in 2008?
Ensure brevity in your answer.  0.98. What is the ratio of the CO2 emissions (% of total fuel combustion) of Latin America(all income levels) in 2006 to that in 2008?
Offer a very short reply. 1.02. What is the ratio of the CO2 emissions (% of total fuel combustion) in Germany in 2006 to that in 2008?
Offer a very short reply. 0.96. What is the ratio of the CO2 emissions (% of total fuel combustion) in Euro area in 2006 to that in 2009?
Provide a succinct answer. 1.07. What is the ratio of the CO2 emissions (% of total fuel combustion) in Latin America(all income levels) in 2006 to that in 2009?
Make the answer very short. 1.08. What is the ratio of the CO2 emissions (% of total fuel combustion) in Germany in 2006 to that in 2009?
Offer a terse response. 1.02. What is the ratio of the CO2 emissions (% of total fuel combustion) in Euro area in 2006 to that in 2010?
Give a very brief answer. 1.02. What is the ratio of the CO2 emissions (% of total fuel combustion) in Latin America(all income levels) in 2006 to that in 2010?
Provide a short and direct response. 1.03. What is the ratio of the CO2 emissions (% of total fuel combustion) of Germany in 2006 to that in 2010?
Make the answer very short. 0.96. What is the ratio of the CO2 emissions (% of total fuel combustion) of Euro area in 2007 to that in 2008?
Offer a very short reply. 1.01. What is the ratio of the CO2 emissions (% of total fuel combustion) of Latin America(all income levels) in 2007 to that in 2008?
Give a very brief answer. 0.97. What is the ratio of the CO2 emissions (% of total fuel combustion) in Germany in 2007 to that in 2008?
Keep it short and to the point. 0.99. What is the ratio of the CO2 emissions (% of total fuel combustion) of Euro area in 2007 to that in 2009?
Your answer should be very brief. 1.11. What is the ratio of the CO2 emissions (% of total fuel combustion) in Latin America(all income levels) in 2007 to that in 2009?
Offer a very short reply. 1.03. What is the ratio of the CO2 emissions (% of total fuel combustion) in Germany in 2007 to that in 2009?
Offer a terse response. 1.05. What is the ratio of the CO2 emissions (% of total fuel combustion) in Euro area in 2007 to that in 2010?
Make the answer very short. 1.06. What is the ratio of the CO2 emissions (% of total fuel combustion) in Latin America(all income levels) in 2007 to that in 2010?
Your answer should be compact. 0.98. What is the ratio of the CO2 emissions (% of total fuel combustion) in Euro area in 2008 to that in 2009?
Make the answer very short. 1.1. What is the ratio of the CO2 emissions (% of total fuel combustion) of Latin America(all income levels) in 2008 to that in 2009?
Keep it short and to the point. 1.06. What is the ratio of the CO2 emissions (% of total fuel combustion) in Germany in 2008 to that in 2009?
Offer a terse response. 1.06. What is the ratio of the CO2 emissions (% of total fuel combustion) of Euro area in 2008 to that in 2010?
Offer a terse response. 1.05. What is the ratio of the CO2 emissions (% of total fuel combustion) in Latin America(all income levels) in 2008 to that in 2010?
Offer a terse response. 1. What is the ratio of the CO2 emissions (% of total fuel combustion) of Germany in 2008 to that in 2010?
Ensure brevity in your answer.  1. What is the ratio of the CO2 emissions (% of total fuel combustion) in Euro area in 2009 to that in 2010?
Give a very brief answer. 0.95. What is the ratio of the CO2 emissions (% of total fuel combustion) in Latin America(all income levels) in 2009 to that in 2010?
Ensure brevity in your answer.  0.95. What is the ratio of the CO2 emissions (% of total fuel combustion) in Germany in 2009 to that in 2010?
Your answer should be very brief. 0.95. What is the difference between the highest and the second highest CO2 emissions (% of total fuel combustion) in Euro area?
Keep it short and to the point. 0.69. What is the difference between the highest and the second highest CO2 emissions (% of total fuel combustion) of Latin America(all income levels)?
Keep it short and to the point. 0.08. What is the difference between the highest and the second highest CO2 emissions (% of total fuel combustion) in Germany?
Ensure brevity in your answer.  0.03. What is the difference between the highest and the lowest CO2 emissions (% of total fuel combustion) of Euro area?
Keep it short and to the point. 2.53. What is the difference between the highest and the lowest CO2 emissions (% of total fuel combustion) of Latin America(all income levels)?
Provide a short and direct response. 1.82. What is the difference between the highest and the lowest CO2 emissions (% of total fuel combustion) in Germany?
Offer a terse response. 0.86. 